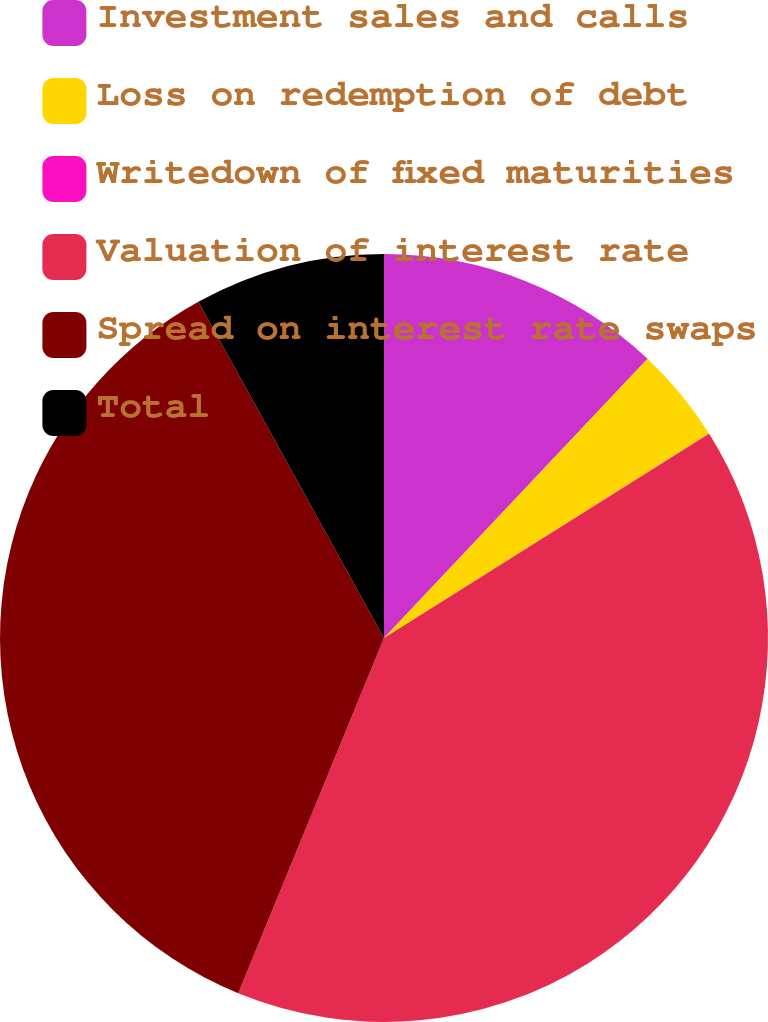Convert chart. <chart><loc_0><loc_0><loc_500><loc_500><pie_chart><fcel>Investment sales and calls<fcel>Loss on redemption of debt<fcel>Writedown of fixed maturities<fcel>Valuation of interest rate<fcel>Spread on interest rate swaps<fcel>Total<nl><fcel>12.04%<fcel>4.02%<fcel>0.01%<fcel>40.12%<fcel>35.77%<fcel>8.03%<nl></chart> 